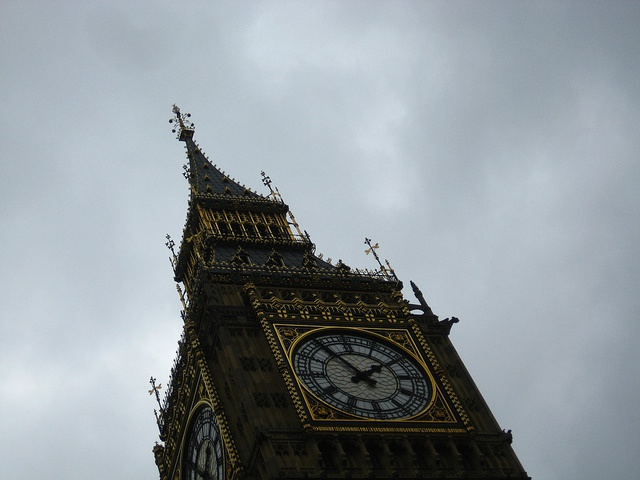Describe the objects in this image and their specific colors. I can see clock in darkgray, black, gray, and olive tones and clock in darkgray, black, gray, and darkgreen tones in this image. 